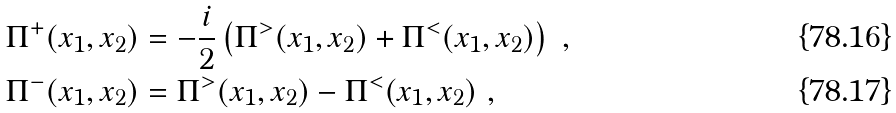Convert formula to latex. <formula><loc_0><loc_0><loc_500><loc_500>\Pi ^ { + } ( x _ { 1 } , x _ { 2 } ) & = - \frac { i } { 2 } \left ( \Pi ^ { > } ( x _ { 1 } , x _ { 2 } ) + \Pi ^ { < } ( x _ { 1 } , x _ { 2 } ) \right ) \ , \\ \Pi ^ { - } ( x _ { 1 } , x _ { 2 } ) & = \Pi ^ { > } ( x _ { 1 } , x _ { 2 } ) - \Pi ^ { < } ( x _ { 1 } , x _ { 2 } ) \ ,</formula> 